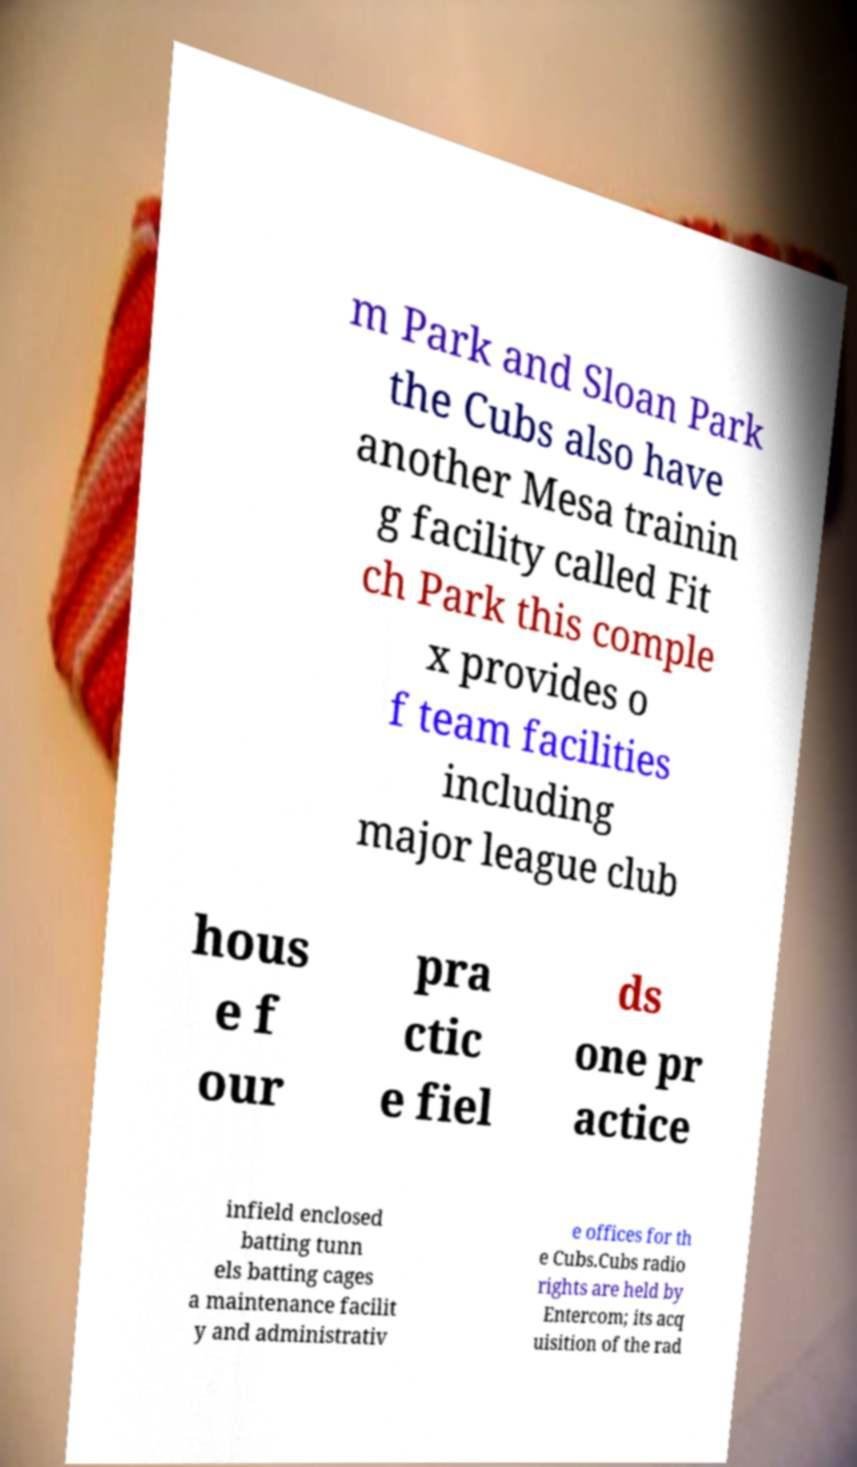Could you assist in decoding the text presented in this image and type it out clearly? m Park and Sloan Park the Cubs also have another Mesa trainin g facility called Fit ch Park this comple x provides o f team facilities including major league club hous e f our pra ctic e fiel ds one pr actice infield enclosed batting tunn els batting cages a maintenance facilit y and administrativ e offices for th e Cubs.Cubs radio rights are held by Entercom; its acq uisition of the rad 